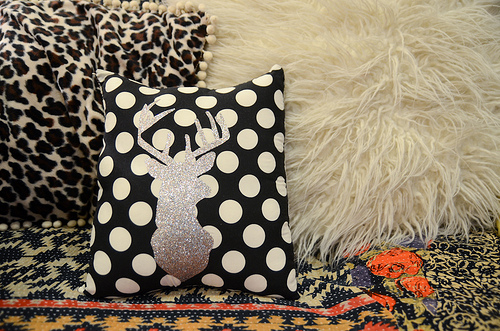<image>
Is there a polka dot on the blanket? No. The polka dot is not positioned on the blanket. They may be near each other, but the polka dot is not supported by or resting on top of the blanket. Is the white pillow behind the deer pillow? Yes. From this viewpoint, the white pillow is positioned behind the deer pillow, with the deer pillow partially or fully occluding the white pillow. 